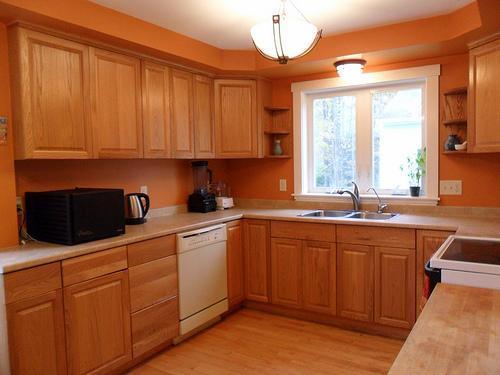How many windows are in this photo?
Give a very brief answer. 1. 